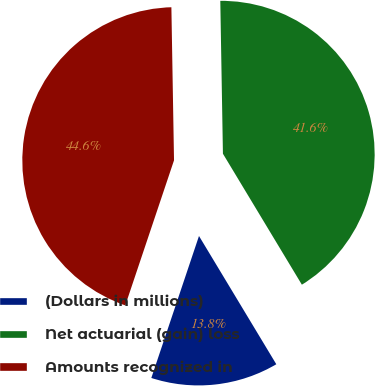<chart> <loc_0><loc_0><loc_500><loc_500><pie_chart><fcel>(Dollars in millions)<fcel>Net actuarial (gain) loss<fcel>Amounts recognized in<nl><fcel>13.79%<fcel>41.64%<fcel>44.57%<nl></chart> 